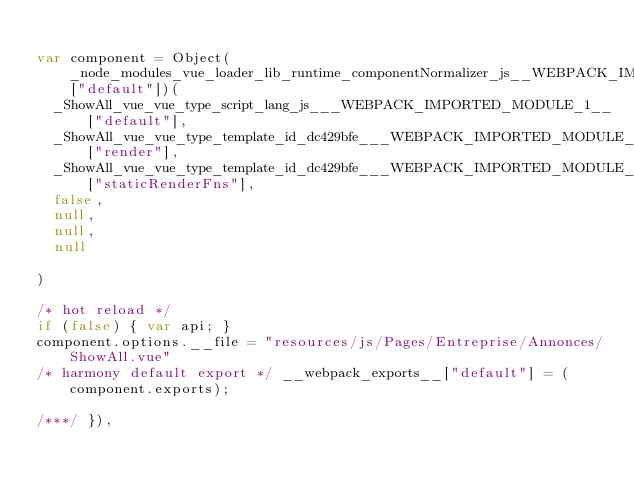<code> <loc_0><loc_0><loc_500><loc_500><_JavaScript_>
var component = Object(_node_modules_vue_loader_lib_runtime_componentNormalizer_js__WEBPACK_IMPORTED_MODULE_2__["default"])(
  _ShowAll_vue_vue_type_script_lang_js___WEBPACK_IMPORTED_MODULE_1__["default"],
  _ShowAll_vue_vue_type_template_id_dc429bfe___WEBPACK_IMPORTED_MODULE_0__["render"],
  _ShowAll_vue_vue_type_template_id_dc429bfe___WEBPACK_IMPORTED_MODULE_0__["staticRenderFns"],
  false,
  null,
  null,
  null
  
)

/* hot reload */
if (false) { var api; }
component.options.__file = "resources/js/Pages/Entreprise/Annonces/ShowAll.vue"
/* harmony default export */ __webpack_exports__["default"] = (component.exports);

/***/ }),
</code> 